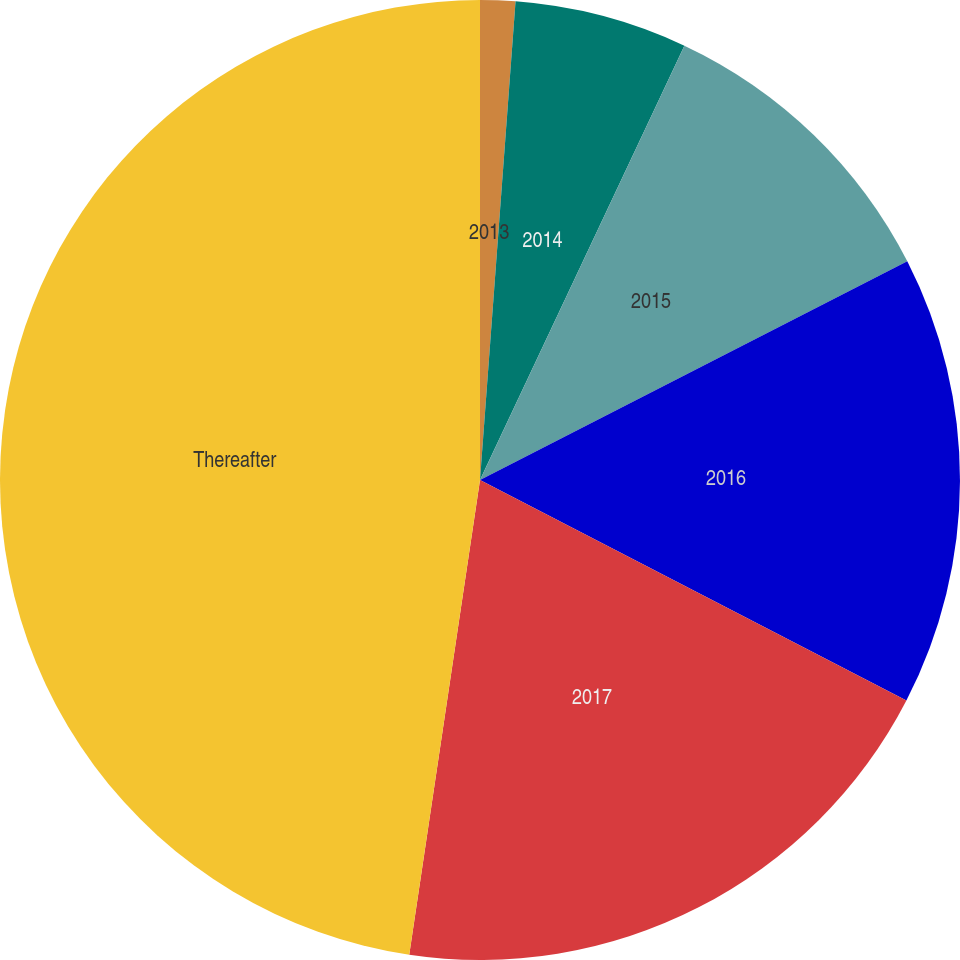Convert chart to OTSL. <chart><loc_0><loc_0><loc_500><loc_500><pie_chart><fcel>2013<fcel>2014<fcel>2015<fcel>2016<fcel>2017<fcel>Thereafter<nl><fcel>1.18%<fcel>5.82%<fcel>10.47%<fcel>15.12%<fcel>19.76%<fcel>47.64%<nl></chart> 